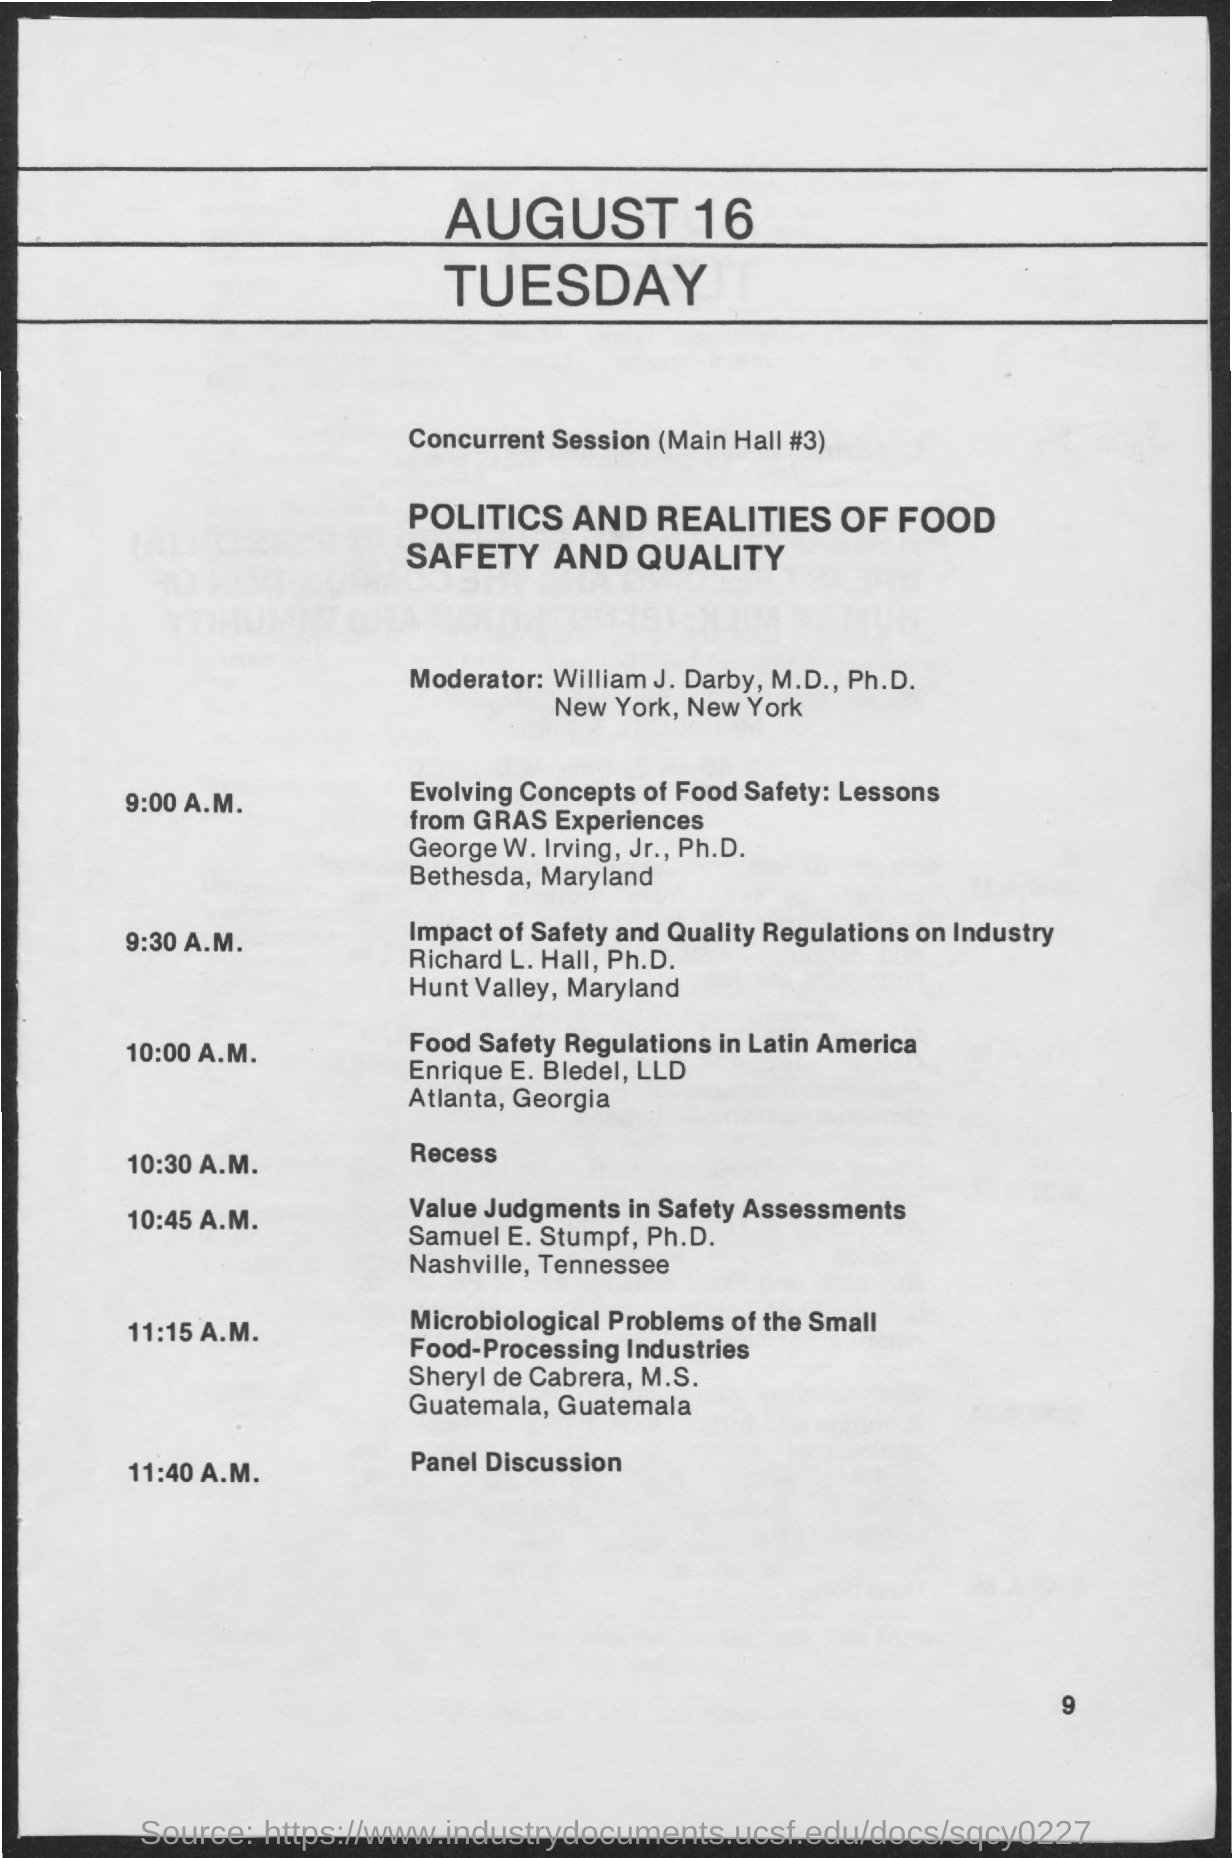Outline some significant characteristics in this image. At 11:40 A.M., a panel discussion is scheduled to take place. At 10:30 A.M., the schedule is as follows: recess. The date mentioned in the given page is August 16, which is a Tuesday. The moderator's name mentioned in the given page is William J. Darby. The title for the topic of the concurrent session as mentioned on the given page is "Politics and Realities of Food Safety and Quality". 